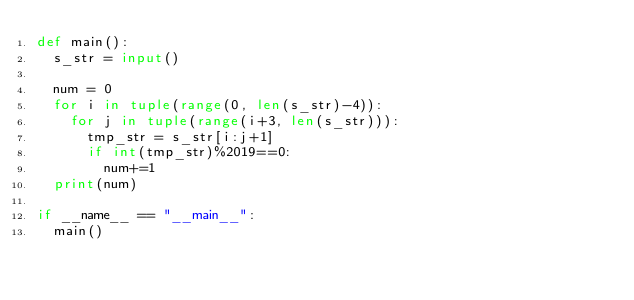<code> <loc_0><loc_0><loc_500><loc_500><_Python_>def main(): 
  s_str = input()

  num = 0
  for i in tuple(range(0, len(s_str)-4)):
    for j in tuple(range(i+3, len(s_str))):
      tmp_str = s_str[i:j+1]
      if int(tmp_str)%2019==0:
        num+=1
  print(num)

if __name__ == "__main__":
  main()</code> 